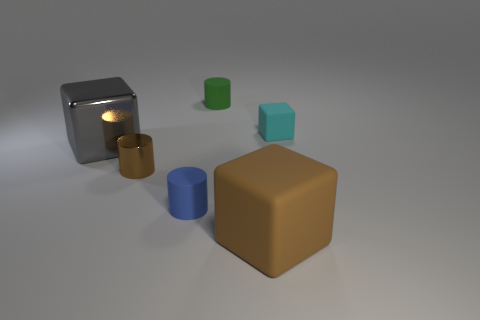Subtract all small cubes. How many cubes are left? 2 Add 2 gray blocks. How many objects exist? 8 Subtract all gray cubes. How many cubes are left? 2 Subtract 1 blocks. How many blocks are left? 2 Subtract all yellow cylinders. Subtract all brown balls. How many cylinders are left? 3 Subtract all small blue rubber cylinders. Subtract all big brown matte cubes. How many objects are left? 4 Add 6 blue cylinders. How many blue cylinders are left? 7 Add 1 large cyan objects. How many large cyan objects exist? 1 Subtract 0 blue blocks. How many objects are left? 6 